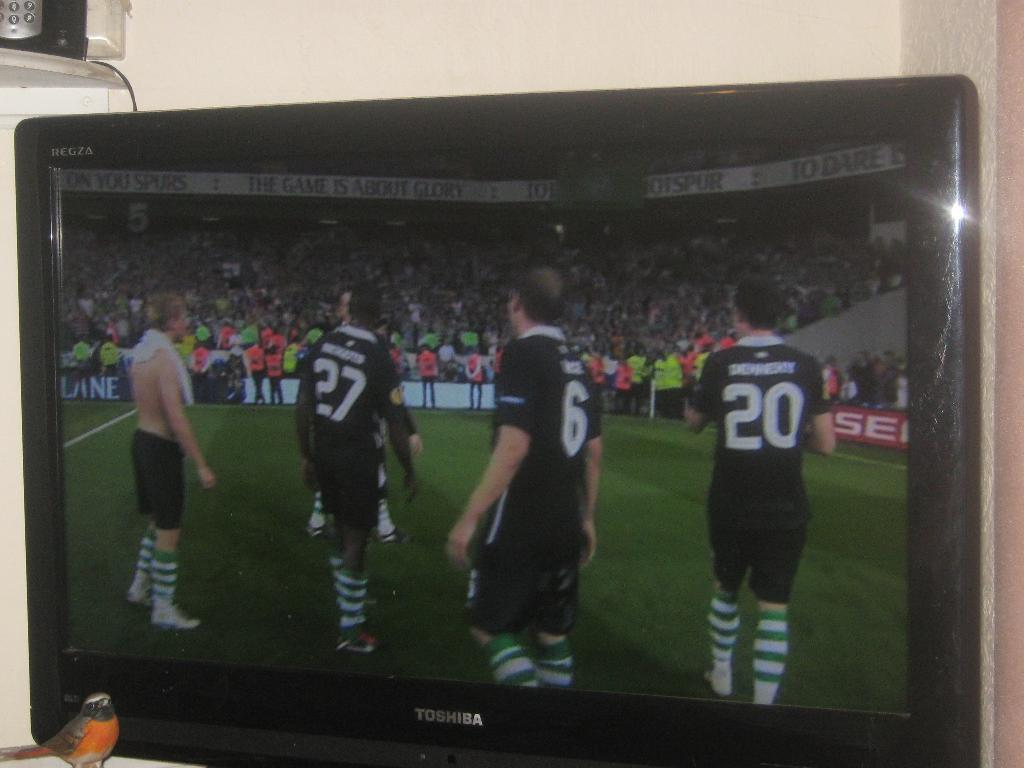What electronic device can be seen in the image? There is a television in the image. What is being displayed on the television screen? There are people visible on the television screen. What type of face can be seen on the television screen? There is no face present on the television screen; it displays people. Can you tell me what request the people on the television screen are making? There is no information about any requests being made by the people on the television screen. 